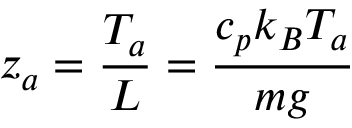<formula> <loc_0><loc_0><loc_500><loc_500>z _ { a } = { \frac { T _ { a } } { L } } = { \frac { c _ { p } k _ { B } T _ { a } } { m g } }</formula> 